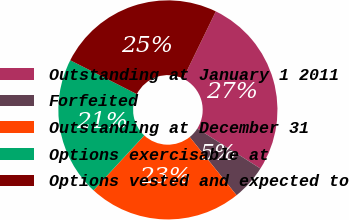Convert chart to OTSL. <chart><loc_0><loc_0><loc_500><loc_500><pie_chart><fcel>Outstanding at January 1 2011<fcel>Forfeited<fcel>Outstanding at December 31<fcel>Options exercisable at<fcel>Options vested and expected to<nl><fcel>26.78%<fcel>5.23%<fcel>22.66%<fcel>20.6%<fcel>24.72%<nl></chart> 